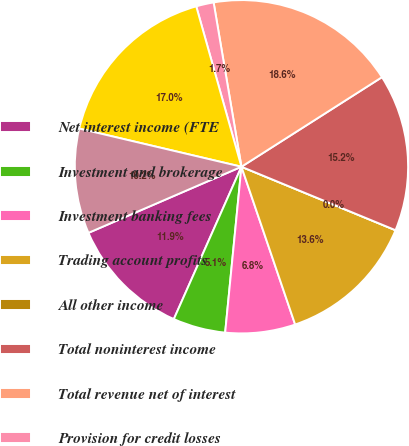Convert chart. <chart><loc_0><loc_0><loc_500><loc_500><pie_chart><fcel>Net interest income (FTE<fcel>Investment and brokerage<fcel>Investment banking fees<fcel>Trading account profits<fcel>All other income<fcel>Total noninterest income<fcel>Total revenue net of interest<fcel>Provision for credit losses<fcel>Noninterest expense<fcel>Income before income taxes<nl><fcel>11.86%<fcel>5.09%<fcel>6.78%<fcel>13.56%<fcel>0.0%<fcel>15.25%<fcel>18.64%<fcel>1.7%<fcel>16.95%<fcel>10.17%<nl></chart> 